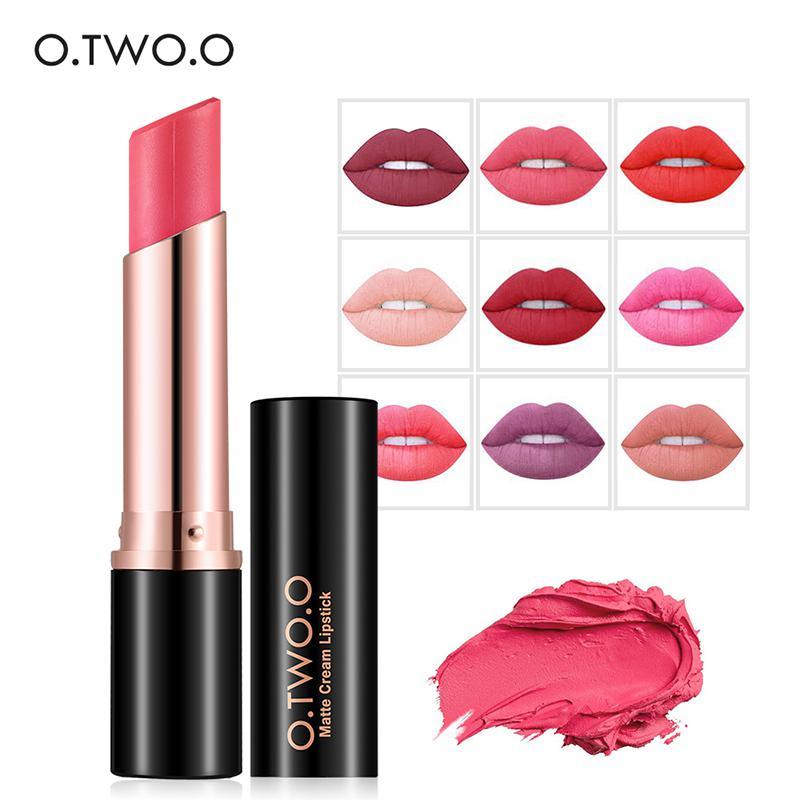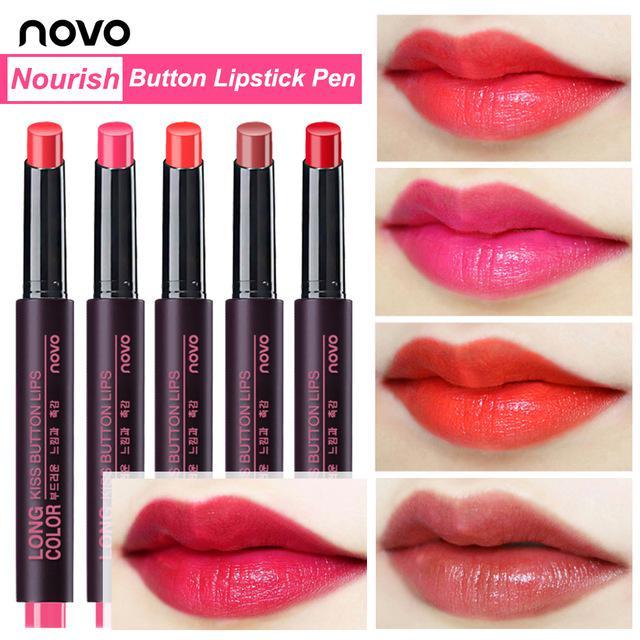The first image is the image on the left, the second image is the image on the right. Assess this claim about the two images: "In one image, a person's face is shown to demonstrate a specific lip color.". Correct or not? Answer yes or no. No. 